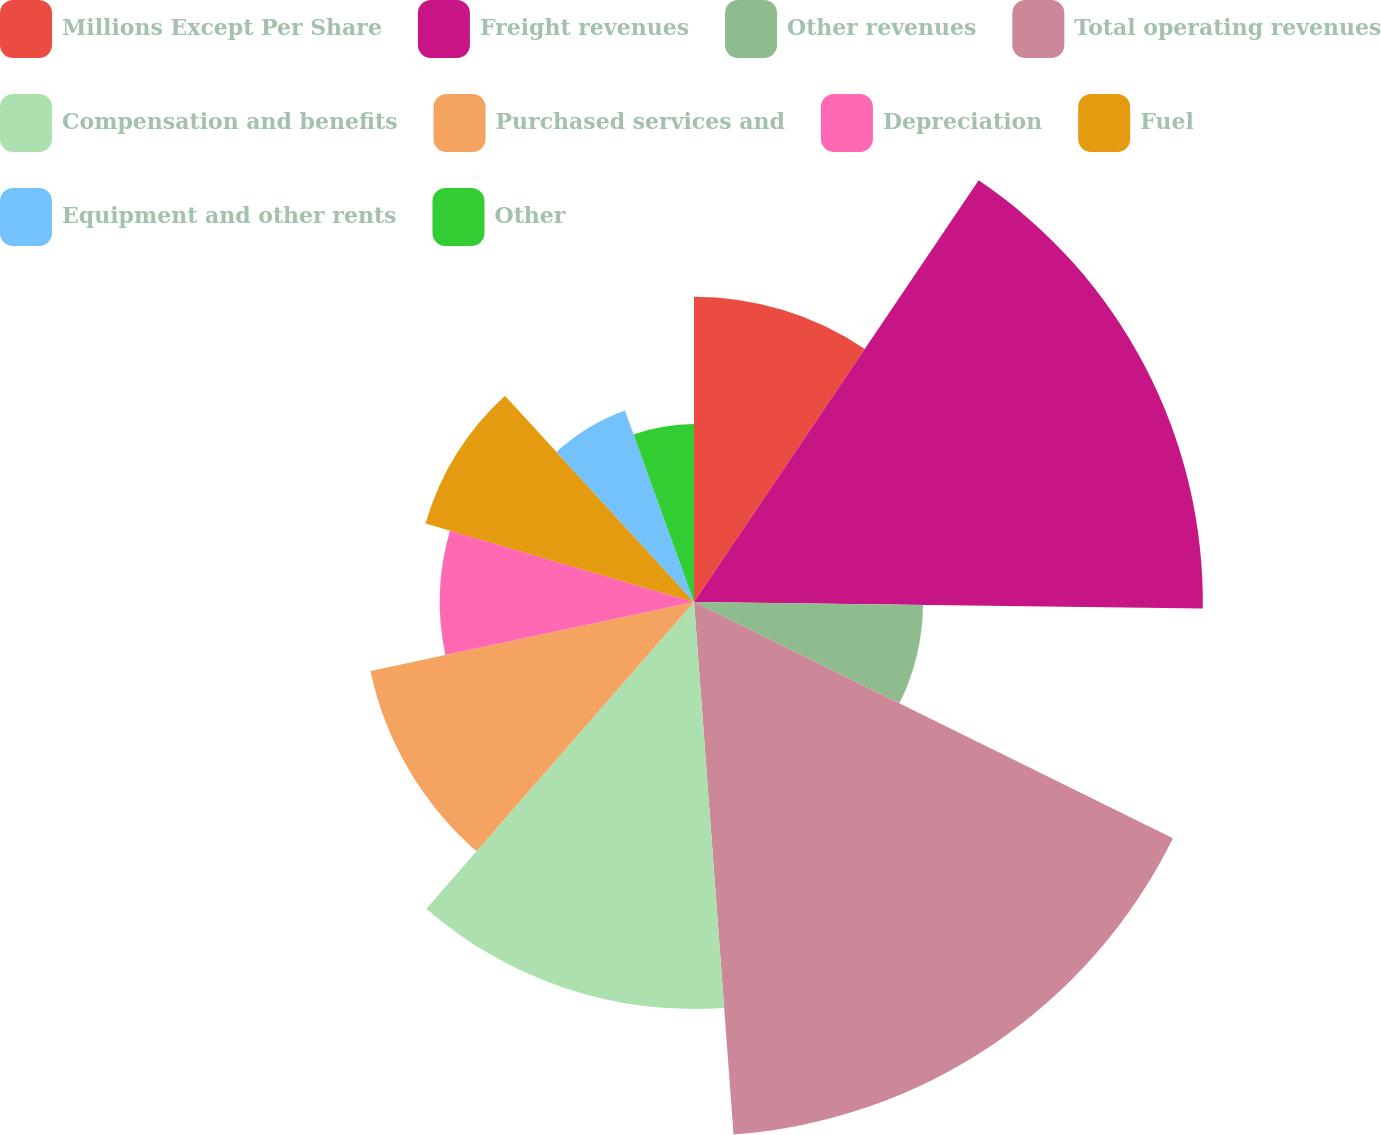Convert chart to OTSL. <chart><loc_0><loc_0><loc_500><loc_500><pie_chart><fcel>Millions Except Per Share<fcel>Freight revenues<fcel>Other revenues<fcel>Total operating revenues<fcel>Compensation and benefits<fcel>Purchased services and<fcel>Depreciation<fcel>Fuel<fcel>Equipment and other rents<fcel>Other<nl><fcel>9.45%<fcel>15.75%<fcel>7.09%<fcel>16.53%<fcel>12.6%<fcel>10.24%<fcel>7.87%<fcel>8.66%<fcel>6.3%<fcel>5.51%<nl></chart> 